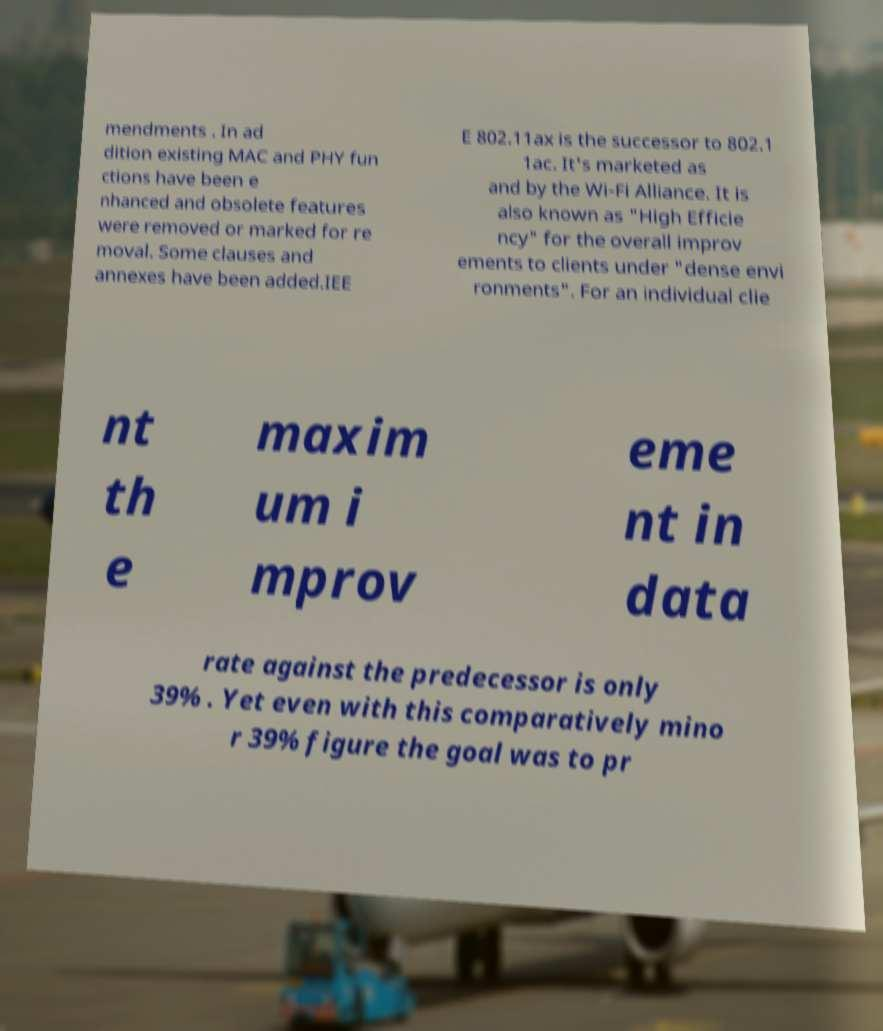What messages or text are displayed in this image? I need them in a readable, typed format. mendments . In ad dition existing MAC and PHY fun ctions have been e nhanced and obsolete features were removed or marked for re moval. Some clauses and annexes have been added.IEE E 802.11ax is the successor to 802.1 1ac. It's marketed as and by the Wi-Fi Alliance. It is also known as "High Efficie ncy" for the overall improv ements to clients under "dense envi ronments". For an individual clie nt th e maxim um i mprov eme nt in data rate against the predecessor is only 39% . Yet even with this comparatively mino r 39% figure the goal was to pr 